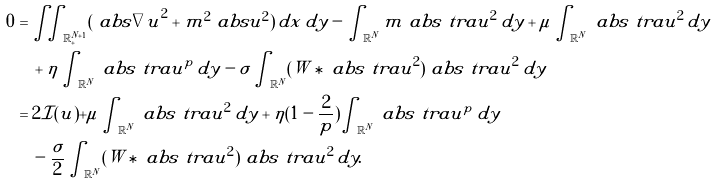<formula> <loc_0><loc_0><loc_500><loc_500>0 & = \iint _ { \mathbb { R } ^ { N + 1 } _ { + } } ( \ a b s { \nabla u } ^ { 2 } + m ^ { 2 } \ a b s { u } ^ { 2 } ) \, d x \, d y - \int _ { \mathbb { R } ^ { N } } m \ a b s { \ t r a { u } } ^ { 2 } \, d y + \mu \int _ { \mathbb { R } ^ { N } } \ a b s { \ t r a { u } } ^ { 2 } \, d y \\ & \quad + \eta \int _ { \mathbb { R } ^ { N } } \ a b s { \ t r a { u } } ^ { p } \, d y - \sigma \int _ { \mathbb { R } ^ { N } } ( W \ast \ a b s { \ t r a { u } } ^ { 2 } ) \ a b s { \ t r a { u } } ^ { 2 } \, d y \\ & = 2 \mathcal { I } ( u ) + \mu \int _ { \mathbb { R } ^ { N } } \ a b s { \ t r a { u } } ^ { 2 } \, d y + \eta ( 1 - \frac { 2 } { p } ) \int _ { \mathbb { R } ^ { N } } \ a b s { \ t r a { u } } ^ { p } \, d y \\ & \quad - \frac { \sigma } { 2 } \int _ { \mathbb { R } ^ { N } } ( W \ast \ a b s { \ t r a { u } } ^ { 2 } ) \ a b s { \ t r a { u } } ^ { 2 } \, d y .</formula> 